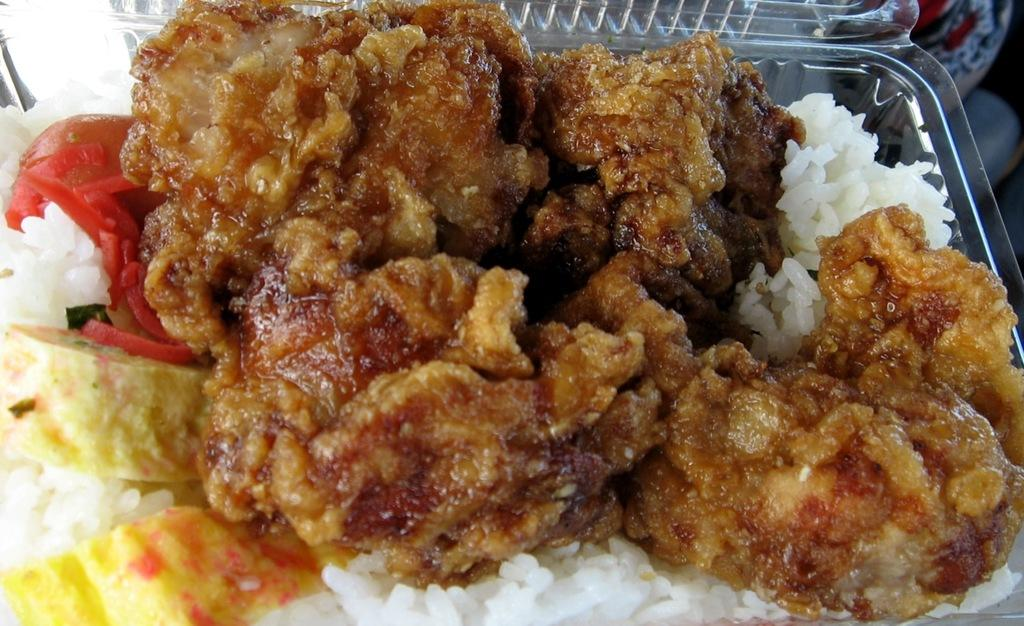What type of container is holding the food in the image? There is food in a box in the image. Can you describe anything visible in the background of the image? There is an object visible in the background of the image. How many horses are present in the image? There are no horses present in the image. What type of shirt is the person wearing in the image? There is no person or shirt visible in the image. 